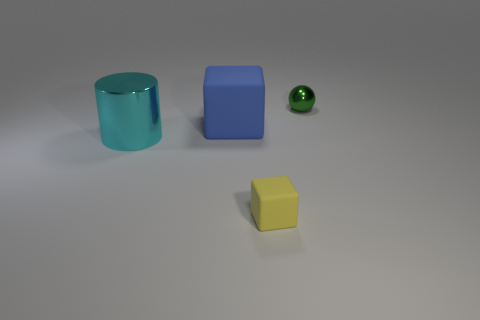Do the metal thing to the right of the large metal object and the metallic thing in front of the tiny green ball have the same shape?
Provide a short and direct response. No. There is a shiny object that is behind the rubber object that is left of the small object that is on the left side of the green thing; what size is it?
Offer a terse response. Small. There is a metallic thing that is on the right side of the small yellow thing; how big is it?
Keep it short and to the point. Small. There is a large object that is in front of the big matte cube; what material is it?
Offer a very short reply. Metal. What number of green things are big matte cubes or shiny spheres?
Keep it short and to the point. 1. Are the large blue block and the small thing left of the green metallic sphere made of the same material?
Make the answer very short. Yes. Is the number of rubber blocks that are left of the tiny matte block the same as the number of small matte cubes that are to the right of the shiny ball?
Your response must be concise. No. Is the size of the yellow thing the same as the metallic object behind the shiny cylinder?
Give a very brief answer. Yes. Is the number of yellow matte objects left of the yellow rubber object greater than the number of yellow blocks?
Your response must be concise. No. What number of green metallic spheres have the same size as the yellow thing?
Give a very brief answer. 1. 